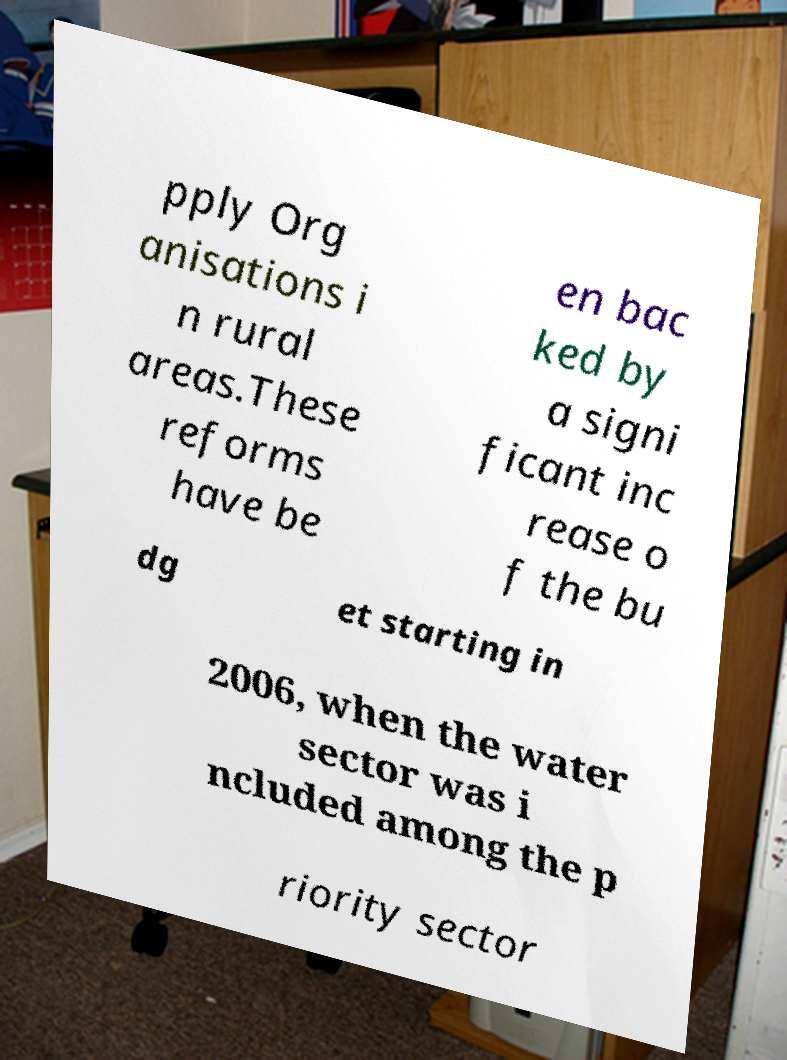Could you assist in decoding the text presented in this image and type it out clearly? pply Org anisations i n rural areas.These reforms have be en bac ked by a signi ficant inc rease o f the bu dg et starting in 2006, when the water sector was i ncluded among the p riority sector 